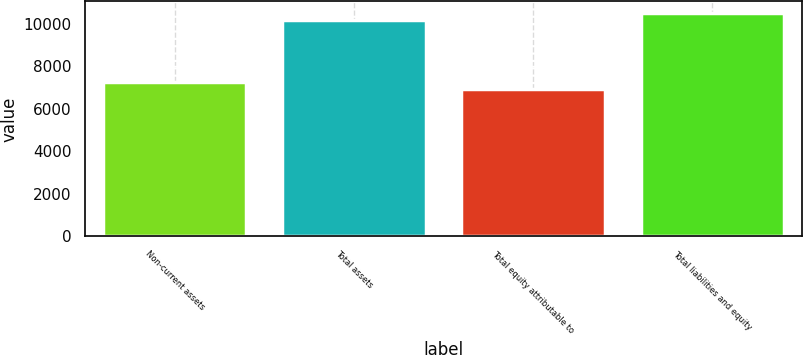Convert chart. <chart><loc_0><loc_0><loc_500><loc_500><bar_chart><fcel>Non-current assets<fcel>Total assets<fcel>Total equity attributable to<fcel>Total liabilities and equity<nl><fcel>7241.77<fcel>10201.6<fcel>6912.9<fcel>10530.5<nl></chart> 